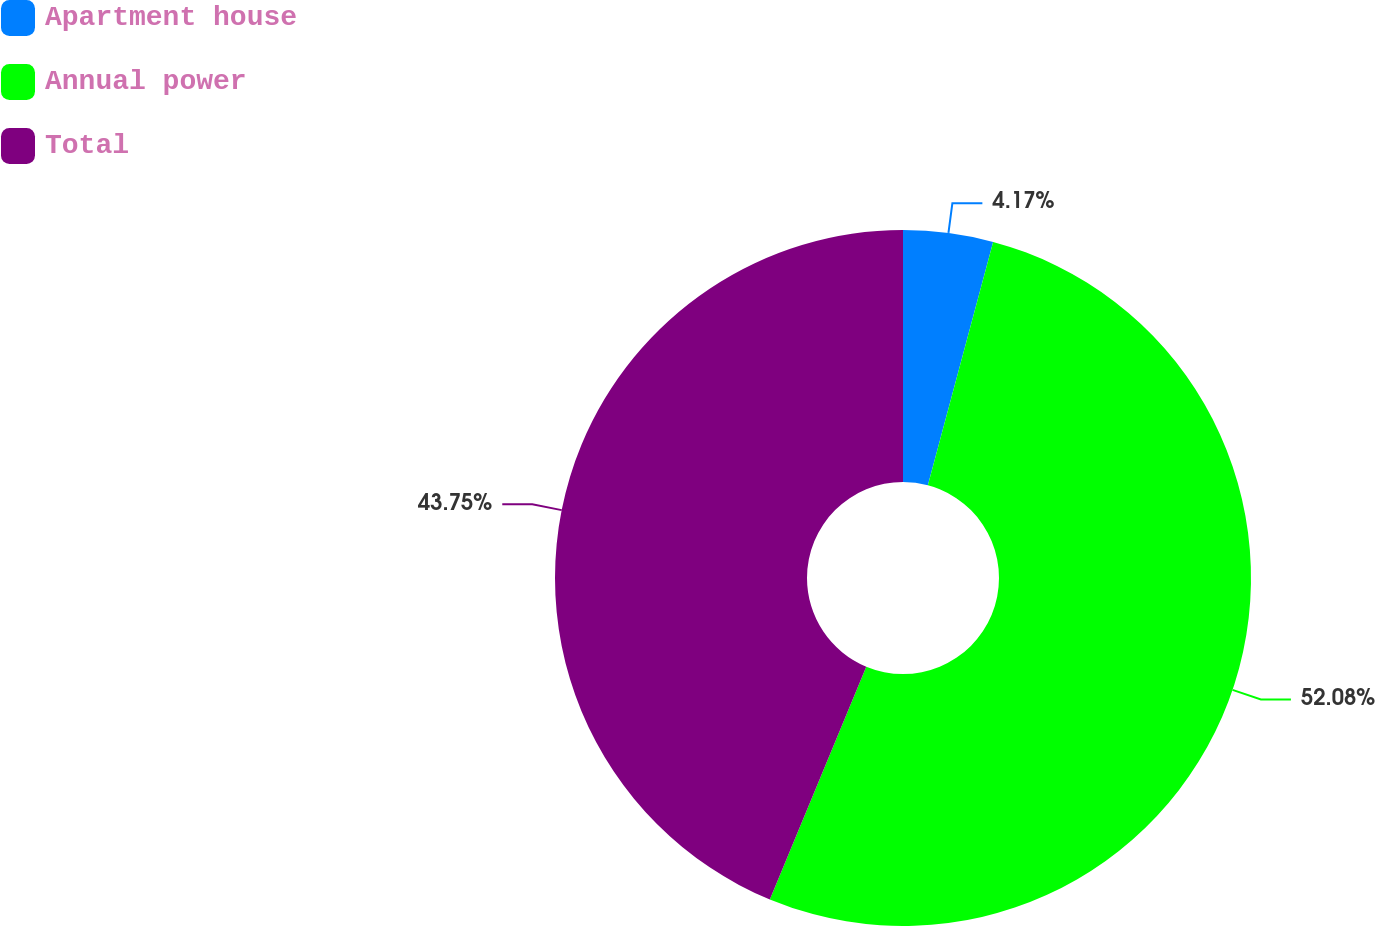Convert chart. <chart><loc_0><loc_0><loc_500><loc_500><pie_chart><fcel>Apartment house<fcel>Annual power<fcel>Total<nl><fcel>4.17%<fcel>52.08%<fcel>43.75%<nl></chart> 